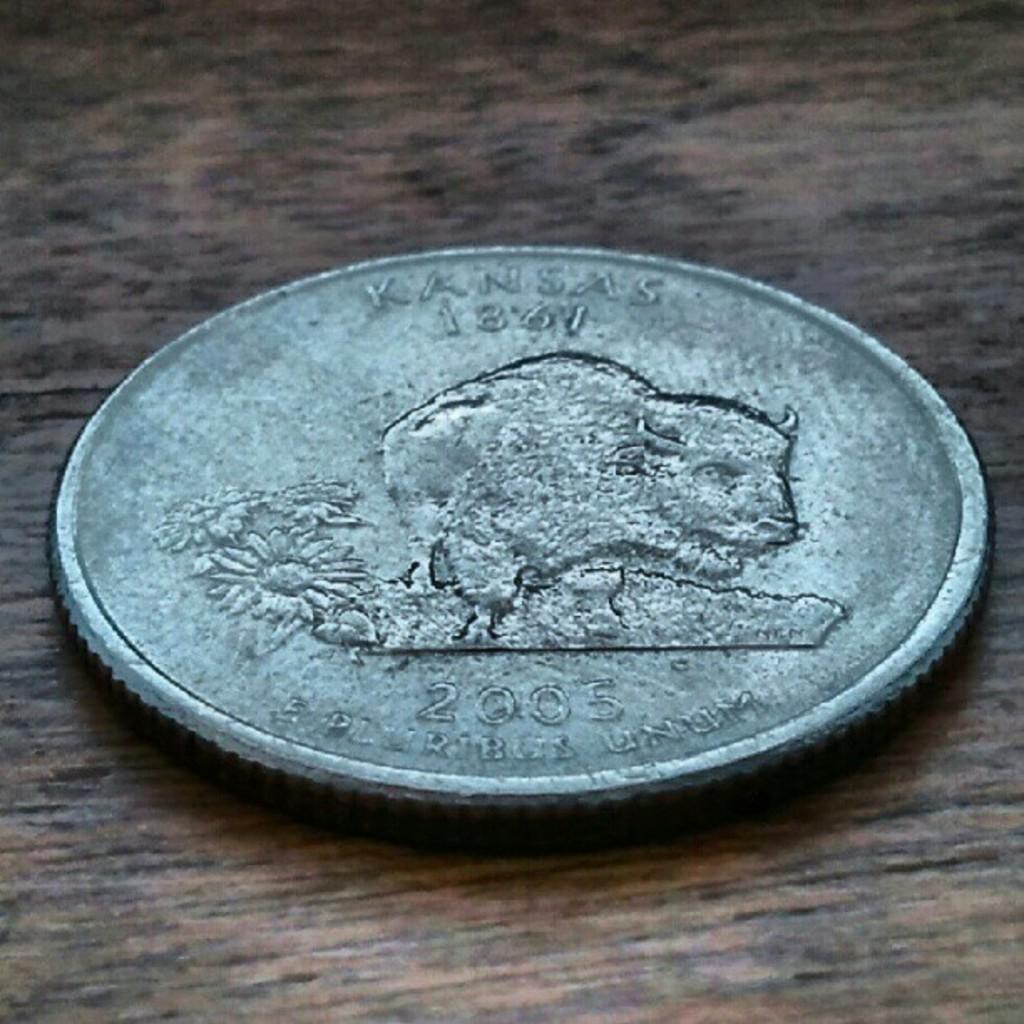What year is this coin from?
Provide a succinct answer. 2005. What state is this coin from?
Offer a very short reply. Kansas. 